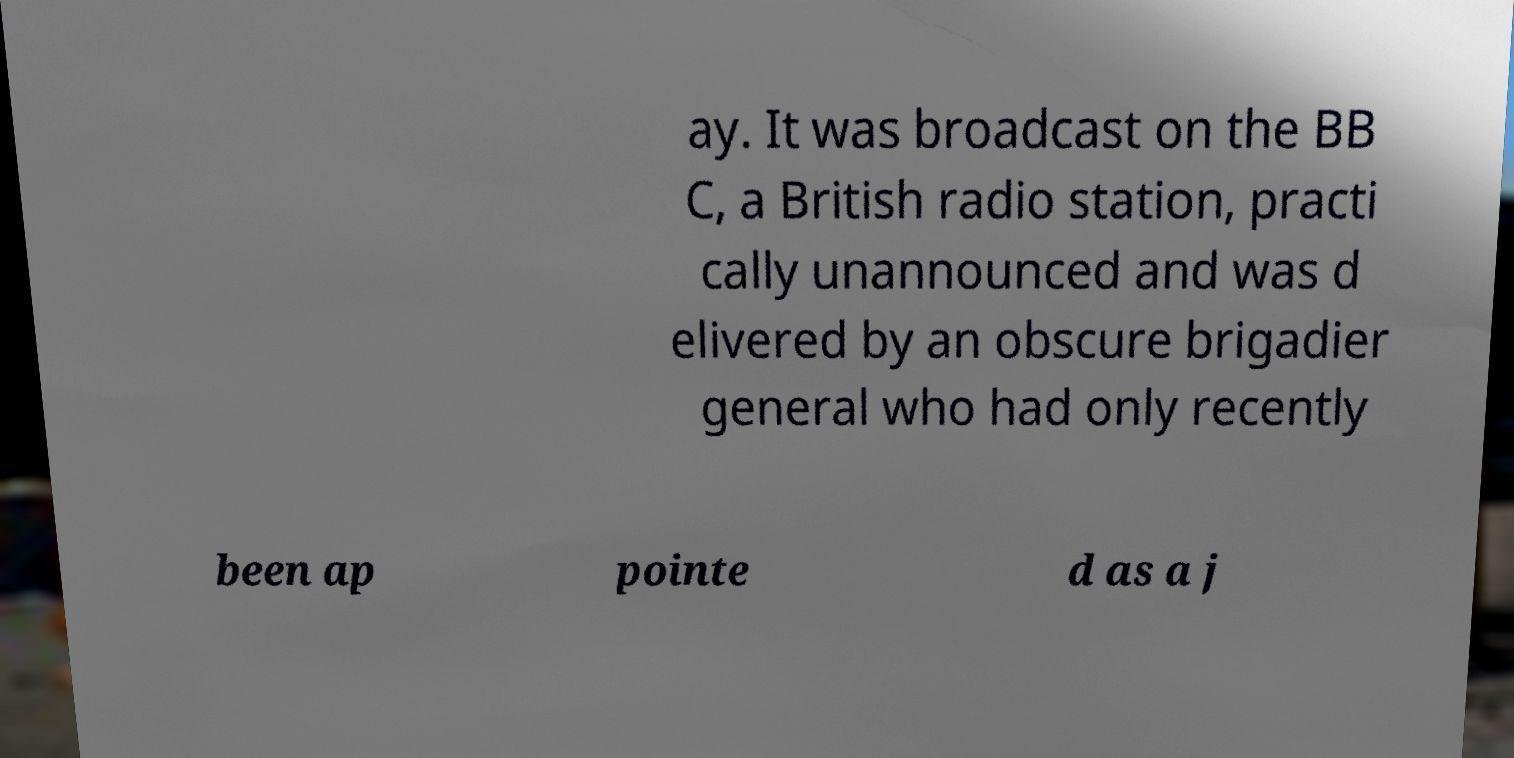Could you assist in decoding the text presented in this image and type it out clearly? ay. It was broadcast on the BB C, a British radio station, practi cally unannounced and was d elivered by an obscure brigadier general who had only recently been ap pointe d as a j 